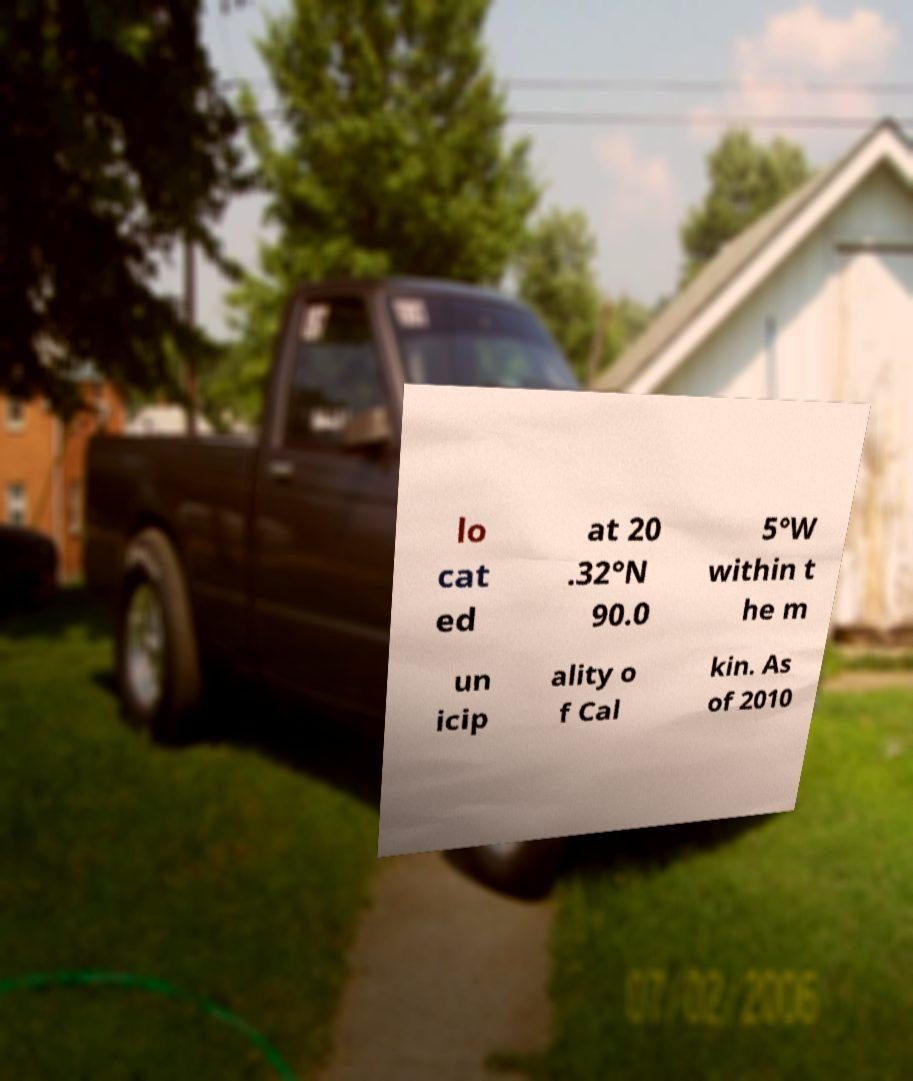For documentation purposes, I need the text within this image transcribed. Could you provide that? lo cat ed at 20 .32°N 90.0 5°W within t he m un icip ality o f Cal kin. As of 2010 